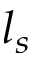<formula> <loc_0><loc_0><loc_500><loc_500>l _ { s }</formula> 